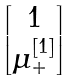Convert formula to latex. <formula><loc_0><loc_0><loc_500><loc_500>\begin{bmatrix} 1 \\ \mu _ { + } ^ { [ 1 ] } \end{bmatrix}</formula> 